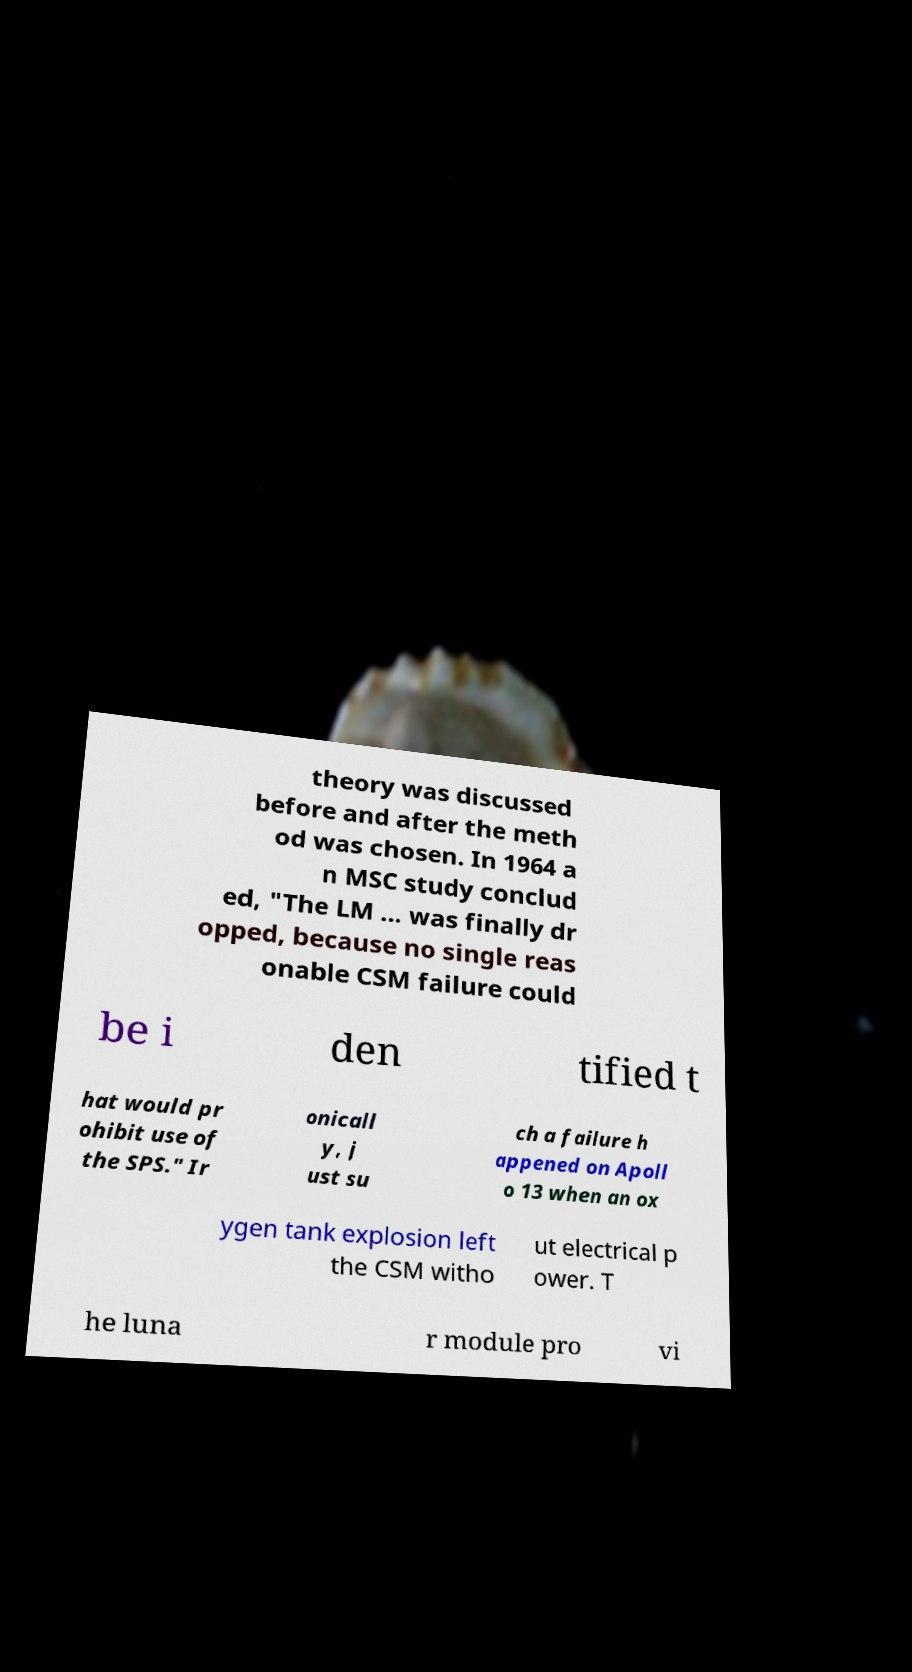What messages or text are displayed in this image? I need them in a readable, typed format. theory was discussed before and after the meth od was chosen. In 1964 a n MSC study conclud ed, "The LM ... was finally dr opped, because no single reas onable CSM failure could be i den tified t hat would pr ohibit use of the SPS." Ir onicall y, j ust su ch a failure h appened on Apoll o 13 when an ox ygen tank explosion left the CSM witho ut electrical p ower. T he luna r module pro vi 